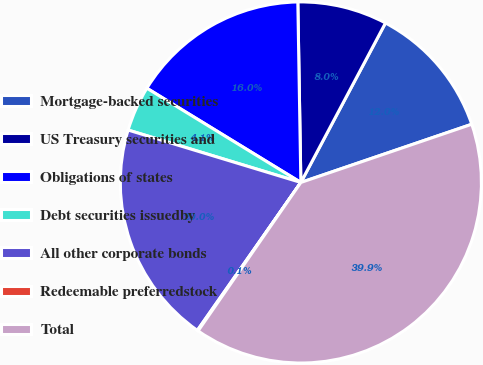Convert chart. <chart><loc_0><loc_0><loc_500><loc_500><pie_chart><fcel>Mortgage-backed securities<fcel>US Treasury securities and<fcel>Obligations of states<fcel>Debt securities issuedby<fcel>All other corporate bonds<fcel>Redeemable preferredstock<fcel>Total<nl><fcel>12.01%<fcel>8.03%<fcel>15.99%<fcel>4.05%<fcel>19.97%<fcel>0.08%<fcel>39.86%<nl></chart> 